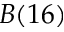Convert formula to latex. <formula><loc_0><loc_0><loc_500><loc_500>B ( 1 6 )</formula> 